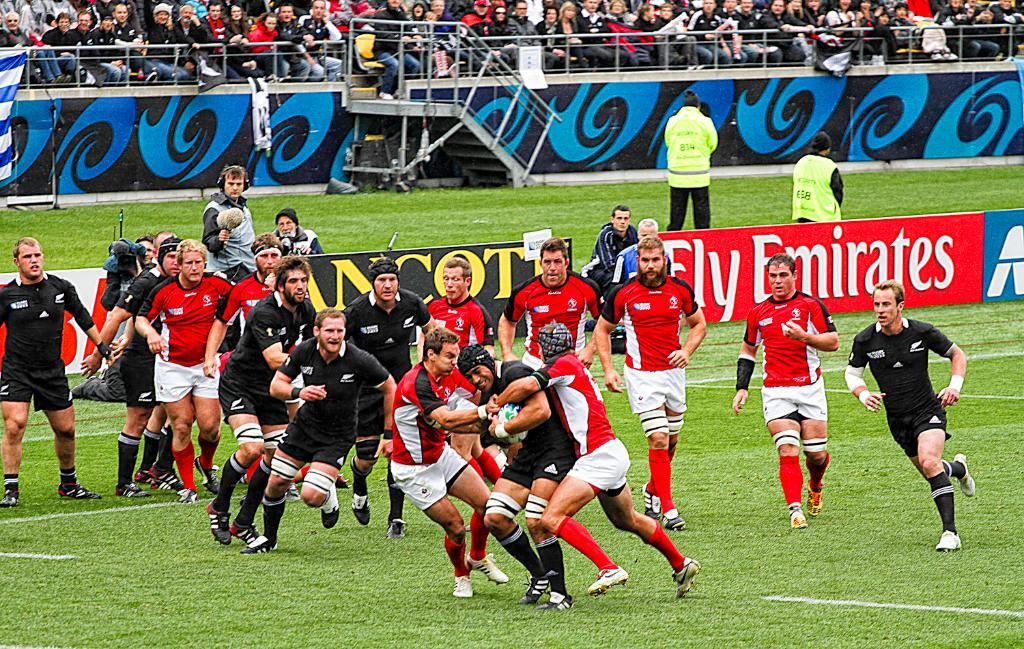<image>
Summarize the visual content of the image. A rugby match being played on a field with a sign to adverstise Fly Emirates. 